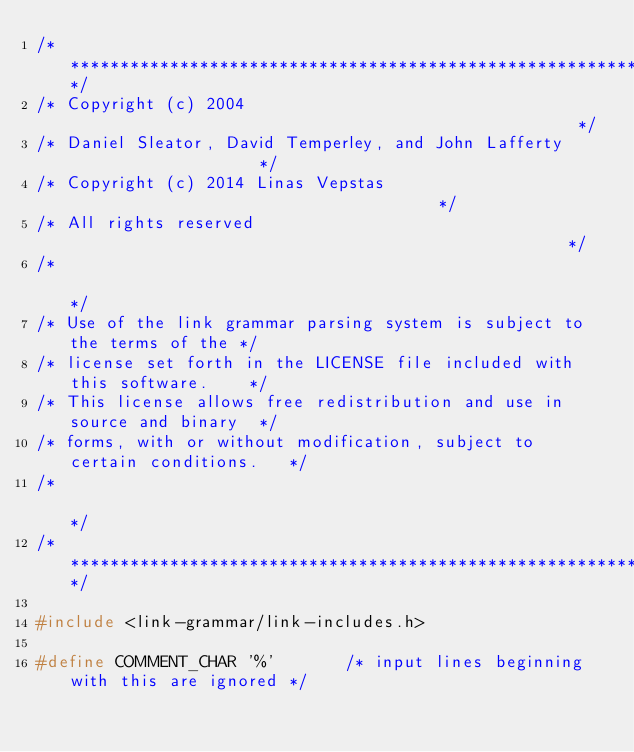Convert code to text. <code><loc_0><loc_0><loc_500><loc_500><_C_>/*************************************************************************/
/* Copyright (c) 2004                                                    */
/* Daniel Sleator, David Temperley, and John Lafferty                    */
/* Copyright (c) 2014 Linas Vepstas                                      */
/* All rights reserved                                                   */
/*                                                                       */
/* Use of the link grammar parsing system is subject to the terms of the */
/* license set forth in the LICENSE file included with this software.    */
/* This license allows free redistribution and use in source and binary  */
/* forms, with or without modification, subject to certain conditions.   */
/*                                                                       */
/*************************************************************************/

#include <link-grammar/link-includes.h>

#define COMMENT_CHAR '%'       /* input lines beginning with this are ignored */</code> 